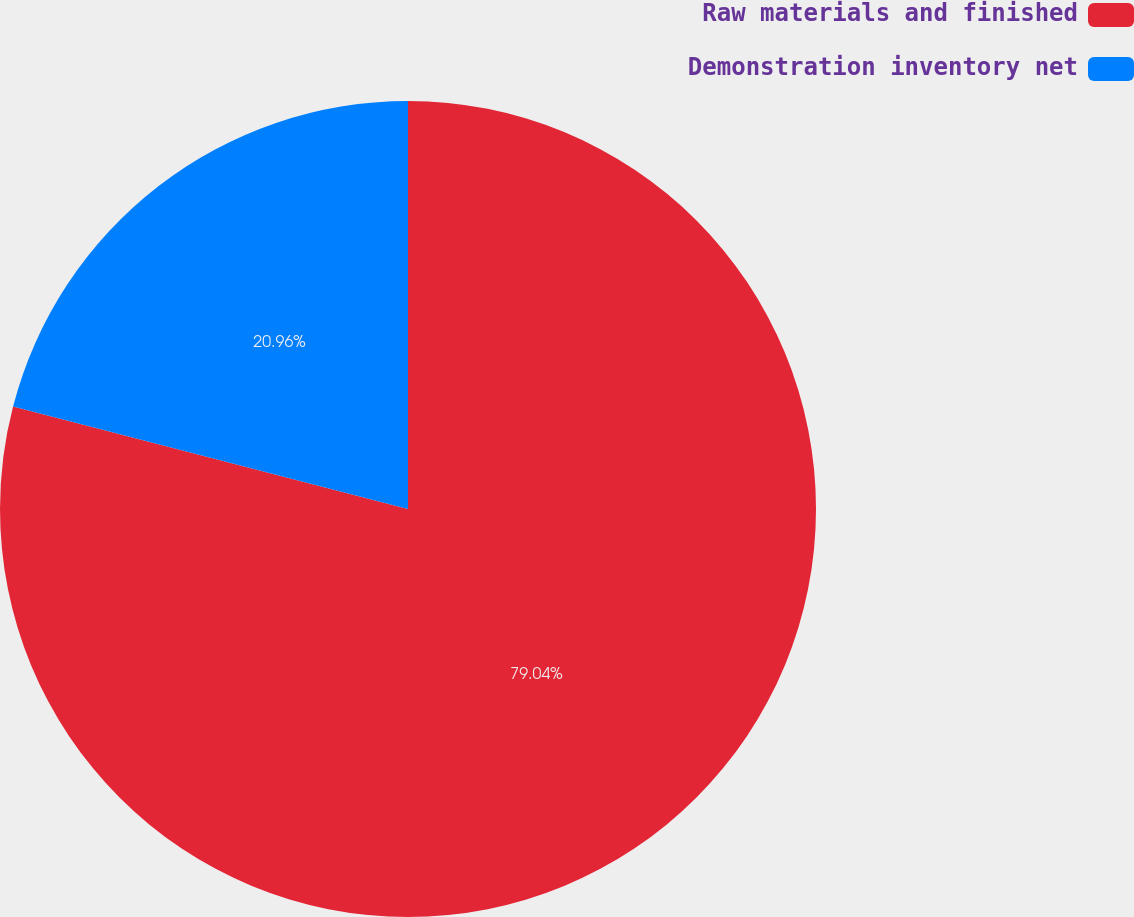Convert chart to OTSL. <chart><loc_0><loc_0><loc_500><loc_500><pie_chart><fcel>Raw materials and finished<fcel>Demonstration inventory net<nl><fcel>79.04%<fcel>20.96%<nl></chart> 